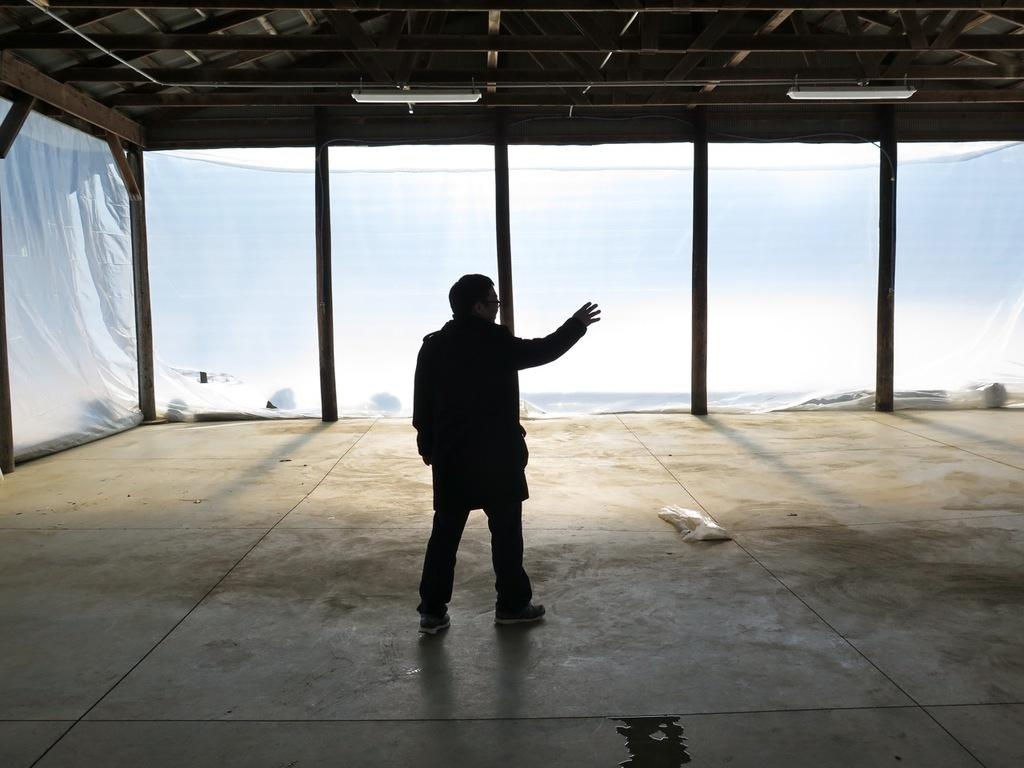What is the main subject of the image? There is a person standing in the image. Where is the person standing? The person is standing on the floor. What can be seen in the background of the image? There are windows and a roof visible in the background of the image. What type of lighting is present in the image? There are ceiling lights on the roof. What type of cloud is floating above the person in the image? There is no cloud visible in the image; the background features windows and a roof. 